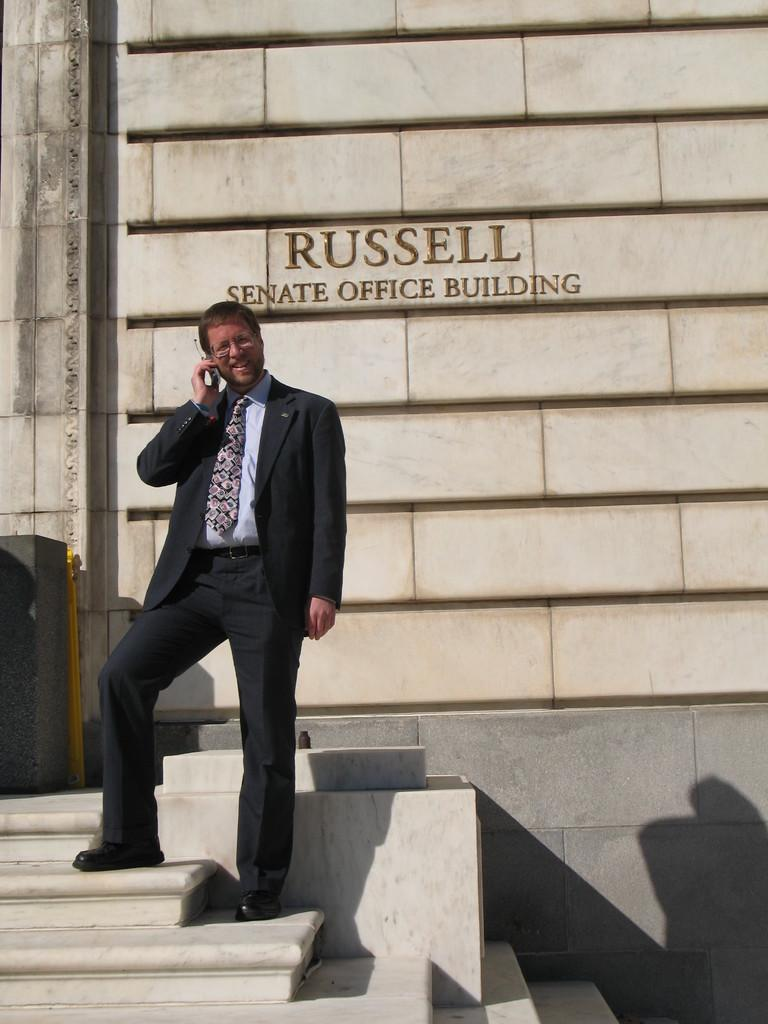What is the main subject of the image? There is a man in the image. Can you describe the background of the image? There is a wall with a name on it in the background of the image. What type of sea creature is swimming near the man in the image? There is no sea creature present in the image; it features a man and a wall with a name on it. What tools might the carpenter be using in the image? There is no carpenter or tools present in the image. Is the man's leg visible in the image? The image does not show the man's leg, so it cannot be determined if it is visible. 